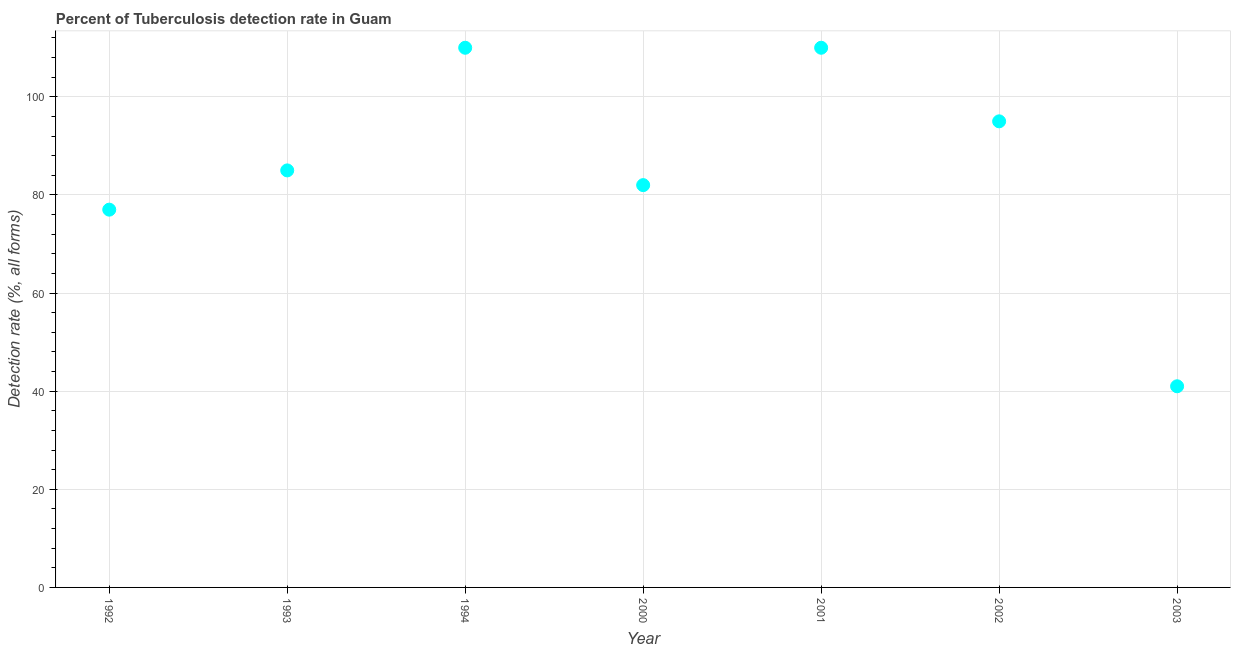What is the detection rate of tuberculosis in 2001?
Your response must be concise. 110. Across all years, what is the maximum detection rate of tuberculosis?
Make the answer very short. 110. Across all years, what is the minimum detection rate of tuberculosis?
Your answer should be very brief. 41. What is the sum of the detection rate of tuberculosis?
Keep it short and to the point. 600. What is the difference between the detection rate of tuberculosis in 1993 and 2000?
Your answer should be very brief. 3. What is the average detection rate of tuberculosis per year?
Offer a terse response. 85.71. What is the median detection rate of tuberculosis?
Provide a short and direct response. 85. What is the ratio of the detection rate of tuberculosis in 1992 to that in 1994?
Give a very brief answer. 0.7. Is the detection rate of tuberculosis in 1993 less than that in 2003?
Ensure brevity in your answer.  No. Is the difference between the detection rate of tuberculosis in 2002 and 2003 greater than the difference between any two years?
Ensure brevity in your answer.  No. Is the sum of the detection rate of tuberculosis in 1992 and 2002 greater than the maximum detection rate of tuberculosis across all years?
Give a very brief answer. Yes. What is the difference between the highest and the lowest detection rate of tuberculosis?
Keep it short and to the point. 69. Does the detection rate of tuberculosis monotonically increase over the years?
Ensure brevity in your answer.  No. How many years are there in the graph?
Your answer should be compact. 7. What is the difference between two consecutive major ticks on the Y-axis?
Offer a very short reply. 20. Are the values on the major ticks of Y-axis written in scientific E-notation?
Provide a succinct answer. No. Does the graph contain any zero values?
Provide a succinct answer. No. What is the title of the graph?
Provide a succinct answer. Percent of Tuberculosis detection rate in Guam. What is the label or title of the Y-axis?
Offer a very short reply. Detection rate (%, all forms). What is the Detection rate (%, all forms) in 1992?
Offer a terse response. 77. What is the Detection rate (%, all forms) in 1994?
Give a very brief answer. 110. What is the Detection rate (%, all forms) in 2000?
Make the answer very short. 82. What is the Detection rate (%, all forms) in 2001?
Make the answer very short. 110. What is the difference between the Detection rate (%, all forms) in 1992 and 1993?
Provide a short and direct response. -8. What is the difference between the Detection rate (%, all forms) in 1992 and 1994?
Keep it short and to the point. -33. What is the difference between the Detection rate (%, all forms) in 1992 and 2001?
Make the answer very short. -33. What is the difference between the Detection rate (%, all forms) in 1992 and 2003?
Ensure brevity in your answer.  36. What is the difference between the Detection rate (%, all forms) in 1993 and 1994?
Your answer should be compact. -25. What is the difference between the Detection rate (%, all forms) in 1993 and 2001?
Provide a short and direct response. -25. What is the difference between the Detection rate (%, all forms) in 1993 and 2002?
Your response must be concise. -10. What is the difference between the Detection rate (%, all forms) in 1994 and 2001?
Your answer should be very brief. 0. What is the difference between the Detection rate (%, all forms) in 1994 and 2002?
Your answer should be compact. 15. What is the difference between the Detection rate (%, all forms) in 1994 and 2003?
Ensure brevity in your answer.  69. What is the difference between the Detection rate (%, all forms) in 2001 and 2002?
Provide a succinct answer. 15. What is the ratio of the Detection rate (%, all forms) in 1992 to that in 1993?
Ensure brevity in your answer.  0.91. What is the ratio of the Detection rate (%, all forms) in 1992 to that in 1994?
Ensure brevity in your answer.  0.7. What is the ratio of the Detection rate (%, all forms) in 1992 to that in 2000?
Give a very brief answer. 0.94. What is the ratio of the Detection rate (%, all forms) in 1992 to that in 2002?
Offer a very short reply. 0.81. What is the ratio of the Detection rate (%, all forms) in 1992 to that in 2003?
Give a very brief answer. 1.88. What is the ratio of the Detection rate (%, all forms) in 1993 to that in 1994?
Your response must be concise. 0.77. What is the ratio of the Detection rate (%, all forms) in 1993 to that in 2000?
Make the answer very short. 1.04. What is the ratio of the Detection rate (%, all forms) in 1993 to that in 2001?
Your response must be concise. 0.77. What is the ratio of the Detection rate (%, all forms) in 1993 to that in 2002?
Ensure brevity in your answer.  0.9. What is the ratio of the Detection rate (%, all forms) in 1993 to that in 2003?
Give a very brief answer. 2.07. What is the ratio of the Detection rate (%, all forms) in 1994 to that in 2000?
Offer a very short reply. 1.34. What is the ratio of the Detection rate (%, all forms) in 1994 to that in 2002?
Keep it short and to the point. 1.16. What is the ratio of the Detection rate (%, all forms) in 1994 to that in 2003?
Offer a terse response. 2.68. What is the ratio of the Detection rate (%, all forms) in 2000 to that in 2001?
Make the answer very short. 0.74. What is the ratio of the Detection rate (%, all forms) in 2000 to that in 2002?
Give a very brief answer. 0.86. What is the ratio of the Detection rate (%, all forms) in 2000 to that in 2003?
Your answer should be very brief. 2. What is the ratio of the Detection rate (%, all forms) in 2001 to that in 2002?
Your response must be concise. 1.16. What is the ratio of the Detection rate (%, all forms) in 2001 to that in 2003?
Your response must be concise. 2.68. What is the ratio of the Detection rate (%, all forms) in 2002 to that in 2003?
Offer a very short reply. 2.32. 